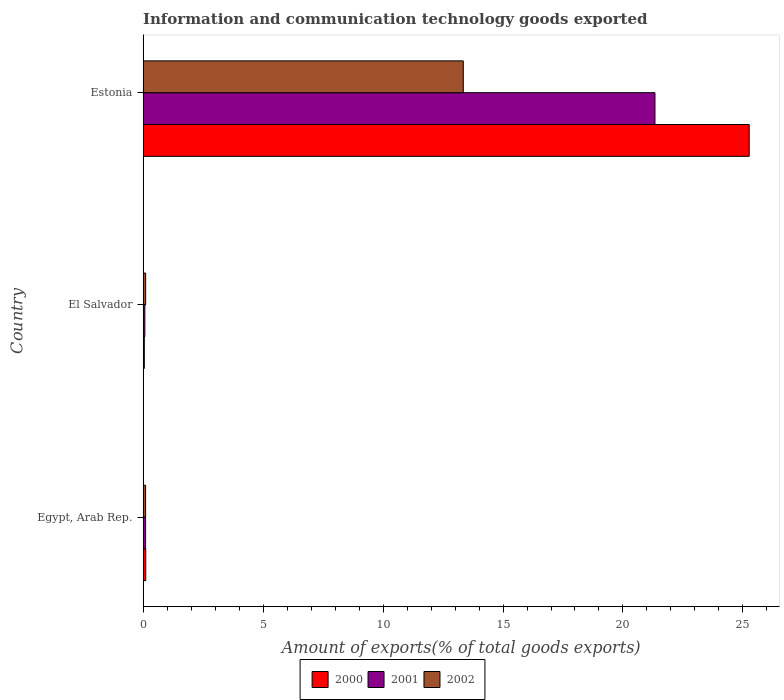How many groups of bars are there?
Make the answer very short. 3. Are the number of bars per tick equal to the number of legend labels?
Ensure brevity in your answer.  Yes. What is the label of the 2nd group of bars from the top?
Provide a short and direct response. El Salvador. What is the amount of goods exported in 2001 in Estonia?
Your answer should be very brief. 21.33. Across all countries, what is the maximum amount of goods exported in 2001?
Provide a short and direct response. 21.33. Across all countries, what is the minimum amount of goods exported in 2002?
Ensure brevity in your answer.  0.11. In which country was the amount of goods exported in 2000 maximum?
Ensure brevity in your answer.  Estonia. In which country was the amount of goods exported in 2001 minimum?
Your response must be concise. El Salvador. What is the total amount of goods exported in 2000 in the graph?
Your response must be concise. 25.42. What is the difference between the amount of goods exported in 2000 in Egypt, Arab Rep. and that in El Salvador?
Make the answer very short. 0.06. What is the difference between the amount of goods exported in 2001 in Estonia and the amount of goods exported in 2002 in Egypt, Arab Rep.?
Ensure brevity in your answer.  21.23. What is the average amount of goods exported in 2000 per country?
Offer a very short reply. 8.47. What is the difference between the amount of goods exported in 2001 and amount of goods exported in 2000 in Estonia?
Make the answer very short. -3.93. In how many countries, is the amount of goods exported in 2000 greater than 20 %?
Make the answer very short. 1. What is the ratio of the amount of goods exported in 2001 in El Salvador to that in Estonia?
Keep it short and to the point. 0. Is the amount of goods exported in 2002 in Egypt, Arab Rep. less than that in Estonia?
Provide a short and direct response. Yes. Is the difference between the amount of goods exported in 2001 in El Salvador and Estonia greater than the difference between the amount of goods exported in 2000 in El Salvador and Estonia?
Offer a very short reply. Yes. What is the difference between the highest and the second highest amount of goods exported in 2000?
Make the answer very short. 25.15. What is the difference between the highest and the lowest amount of goods exported in 2002?
Make the answer very short. 13.24. Is the sum of the amount of goods exported in 2000 in El Salvador and Estonia greater than the maximum amount of goods exported in 2001 across all countries?
Your answer should be very brief. Yes. What does the 3rd bar from the bottom in El Salvador represents?
Make the answer very short. 2002. Is it the case that in every country, the sum of the amount of goods exported in 2002 and amount of goods exported in 2000 is greater than the amount of goods exported in 2001?
Give a very brief answer. Yes. Are all the bars in the graph horizontal?
Offer a terse response. Yes. How many countries are there in the graph?
Your answer should be compact. 3. Are the values on the major ticks of X-axis written in scientific E-notation?
Make the answer very short. No. Does the graph contain any zero values?
Your response must be concise. No. Does the graph contain grids?
Offer a very short reply. No. How many legend labels are there?
Your answer should be very brief. 3. What is the title of the graph?
Your response must be concise. Information and communication technology goods exported. What is the label or title of the X-axis?
Provide a short and direct response. Amount of exports(% of total goods exports). What is the label or title of the Y-axis?
Your answer should be compact. Country. What is the Amount of exports(% of total goods exports) of 2000 in Egypt, Arab Rep.?
Ensure brevity in your answer.  0.11. What is the Amount of exports(% of total goods exports) of 2001 in Egypt, Arab Rep.?
Your answer should be very brief. 0.11. What is the Amount of exports(% of total goods exports) in 2002 in Egypt, Arab Rep.?
Offer a very short reply. 0.11. What is the Amount of exports(% of total goods exports) in 2000 in El Salvador?
Your response must be concise. 0.05. What is the Amount of exports(% of total goods exports) of 2001 in El Salvador?
Ensure brevity in your answer.  0.07. What is the Amount of exports(% of total goods exports) in 2002 in El Salvador?
Your response must be concise. 0.11. What is the Amount of exports(% of total goods exports) in 2000 in Estonia?
Your answer should be compact. 25.26. What is the Amount of exports(% of total goods exports) in 2001 in Estonia?
Provide a succinct answer. 21.33. What is the Amount of exports(% of total goods exports) of 2002 in Estonia?
Keep it short and to the point. 13.34. Across all countries, what is the maximum Amount of exports(% of total goods exports) in 2000?
Keep it short and to the point. 25.26. Across all countries, what is the maximum Amount of exports(% of total goods exports) in 2001?
Your response must be concise. 21.33. Across all countries, what is the maximum Amount of exports(% of total goods exports) in 2002?
Offer a terse response. 13.34. Across all countries, what is the minimum Amount of exports(% of total goods exports) in 2000?
Your answer should be compact. 0.05. Across all countries, what is the minimum Amount of exports(% of total goods exports) of 2001?
Your answer should be very brief. 0.07. Across all countries, what is the minimum Amount of exports(% of total goods exports) of 2002?
Provide a short and direct response. 0.11. What is the total Amount of exports(% of total goods exports) in 2000 in the graph?
Give a very brief answer. 25.42. What is the total Amount of exports(% of total goods exports) in 2001 in the graph?
Keep it short and to the point. 21.51. What is the total Amount of exports(% of total goods exports) in 2002 in the graph?
Keep it short and to the point. 13.56. What is the difference between the Amount of exports(% of total goods exports) in 2000 in Egypt, Arab Rep. and that in El Salvador?
Your answer should be very brief. 0.06. What is the difference between the Amount of exports(% of total goods exports) in 2001 in Egypt, Arab Rep. and that in El Salvador?
Keep it short and to the point. 0.03. What is the difference between the Amount of exports(% of total goods exports) in 2002 in Egypt, Arab Rep. and that in El Salvador?
Provide a short and direct response. -0. What is the difference between the Amount of exports(% of total goods exports) of 2000 in Egypt, Arab Rep. and that in Estonia?
Ensure brevity in your answer.  -25.15. What is the difference between the Amount of exports(% of total goods exports) of 2001 in Egypt, Arab Rep. and that in Estonia?
Offer a terse response. -21.23. What is the difference between the Amount of exports(% of total goods exports) of 2002 in Egypt, Arab Rep. and that in Estonia?
Offer a very short reply. -13.24. What is the difference between the Amount of exports(% of total goods exports) in 2000 in El Salvador and that in Estonia?
Ensure brevity in your answer.  -25.21. What is the difference between the Amount of exports(% of total goods exports) of 2001 in El Salvador and that in Estonia?
Ensure brevity in your answer.  -21.26. What is the difference between the Amount of exports(% of total goods exports) of 2002 in El Salvador and that in Estonia?
Provide a short and direct response. -13.24. What is the difference between the Amount of exports(% of total goods exports) of 2000 in Egypt, Arab Rep. and the Amount of exports(% of total goods exports) of 2001 in El Salvador?
Your answer should be compact. 0.04. What is the difference between the Amount of exports(% of total goods exports) of 2000 in Egypt, Arab Rep. and the Amount of exports(% of total goods exports) of 2002 in El Salvador?
Provide a succinct answer. 0. What is the difference between the Amount of exports(% of total goods exports) of 2001 in Egypt, Arab Rep. and the Amount of exports(% of total goods exports) of 2002 in El Salvador?
Your answer should be very brief. -0. What is the difference between the Amount of exports(% of total goods exports) of 2000 in Egypt, Arab Rep. and the Amount of exports(% of total goods exports) of 2001 in Estonia?
Ensure brevity in your answer.  -21.22. What is the difference between the Amount of exports(% of total goods exports) in 2000 in Egypt, Arab Rep. and the Amount of exports(% of total goods exports) in 2002 in Estonia?
Provide a succinct answer. -13.23. What is the difference between the Amount of exports(% of total goods exports) of 2001 in Egypt, Arab Rep. and the Amount of exports(% of total goods exports) of 2002 in Estonia?
Give a very brief answer. -13.24. What is the difference between the Amount of exports(% of total goods exports) of 2000 in El Salvador and the Amount of exports(% of total goods exports) of 2001 in Estonia?
Give a very brief answer. -21.28. What is the difference between the Amount of exports(% of total goods exports) of 2000 in El Salvador and the Amount of exports(% of total goods exports) of 2002 in Estonia?
Your answer should be very brief. -13.29. What is the difference between the Amount of exports(% of total goods exports) of 2001 in El Salvador and the Amount of exports(% of total goods exports) of 2002 in Estonia?
Offer a terse response. -13.27. What is the average Amount of exports(% of total goods exports) in 2000 per country?
Provide a short and direct response. 8.47. What is the average Amount of exports(% of total goods exports) of 2001 per country?
Provide a succinct answer. 7.17. What is the average Amount of exports(% of total goods exports) of 2002 per country?
Your answer should be compact. 4.52. What is the difference between the Amount of exports(% of total goods exports) of 2000 and Amount of exports(% of total goods exports) of 2001 in Egypt, Arab Rep.?
Keep it short and to the point. 0.01. What is the difference between the Amount of exports(% of total goods exports) in 2000 and Amount of exports(% of total goods exports) in 2002 in Egypt, Arab Rep.?
Make the answer very short. 0.01. What is the difference between the Amount of exports(% of total goods exports) of 2001 and Amount of exports(% of total goods exports) of 2002 in Egypt, Arab Rep.?
Your answer should be compact. -0. What is the difference between the Amount of exports(% of total goods exports) of 2000 and Amount of exports(% of total goods exports) of 2001 in El Salvador?
Keep it short and to the point. -0.02. What is the difference between the Amount of exports(% of total goods exports) in 2000 and Amount of exports(% of total goods exports) in 2002 in El Salvador?
Your response must be concise. -0.06. What is the difference between the Amount of exports(% of total goods exports) in 2001 and Amount of exports(% of total goods exports) in 2002 in El Salvador?
Ensure brevity in your answer.  -0.03. What is the difference between the Amount of exports(% of total goods exports) of 2000 and Amount of exports(% of total goods exports) of 2001 in Estonia?
Keep it short and to the point. 3.93. What is the difference between the Amount of exports(% of total goods exports) of 2000 and Amount of exports(% of total goods exports) of 2002 in Estonia?
Provide a short and direct response. 11.91. What is the difference between the Amount of exports(% of total goods exports) of 2001 and Amount of exports(% of total goods exports) of 2002 in Estonia?
Give a very brief answer. 7.99. What is the ratio of the Amount of exports(% of total goods exports) in 2000 in Egypt, Arab Rep. to that in El Salvador?
Offer a terse response. 2.16. What is the ratio of the Amount of exports(% of total goods exports) in 2001 in Egypt, Arab Rep. to that in El Salvador?
Your response must be concise. 1.43. What is the ratio of the Amount of exports(% of total goods exports) of 2002 in Egypt, Arab Rep. to that in El Salvador?
Give a very brief answer. 0.98. What is the ratio of the Amount of exports(% of total goods exports) in 2000 in Egypt, Arab Rep. to that in Estonia?
Give a very brief answer. 0. What is the ratio of the Amount of exports(% of total goods exports) of 2001 in Egypt, Arab Rep. to that in Estonia?
Provide a succinct answer. 0.01. What is the ratio of the Amount of exports(% of total goods exports) in 2002 in Egypt, Arab Rep. to that in Estonia?
Offer a very short reply. 0.01. What is the ratio of the Amount of exports(% of total goods exports) in 2000 in El Salvador to that in Estonia?
Keep it short and to the point. 0. What is the ratio of the Amount of exports(% of total goods exports) of 2001 in El Salvador to that in Estonia?
Offer a terse response. 0. What is the ratio of the Amount of exports(% of total goods exports) in 2002 in El Salvador to that in Estonia?
Make the answer very short. 0.01. What is the difference between the highest and the second highest Amount of exports(% of total goods exports) in 2000?
Give a very brief answer. 25.15. What is the difference between the highest and the second highest Amount of exports(% of total goods exports) of 2001?
Keep it short and to the point. 21.23. What is the difference between the highest and the second highest Amount of exports(% of total goods exports) of 2002?
Make the answer very short. 13.24. What is the difference between the highest and the lowest Amount of exports(% of total goods exports) in 2000?
Your response must be concise. 25.21. What is the difference between the highest and the lowest Amount of exports(% of total goods exports) of 2001?
Ensure brevity in your answer.  21.26. What is the difference between the highest and the lowest Amount of exports(% of total goods exports) of 2002?
Your answer should be compact. 13.24. 